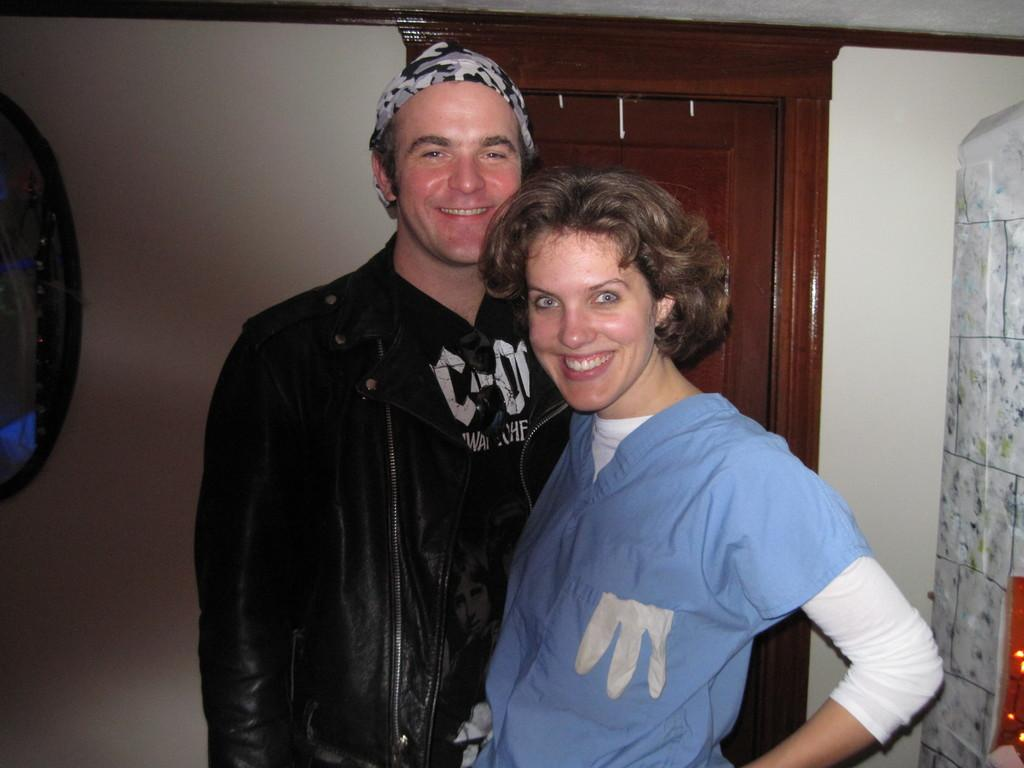How many people are in the image? There are two people in the image, a man and a woman. What are the expressions on their faces? Both the man and the woman are smiling in the image. What are they doing in the image? The man and the woman are posing for a photo. What can be seen behind them in the image? There is a wardrobe behind them, and a wall in the background. What type of rock is the man holding in the image? There is no rock present in the image; the man and woman are posing for a photo with no visible objects in their hands. 